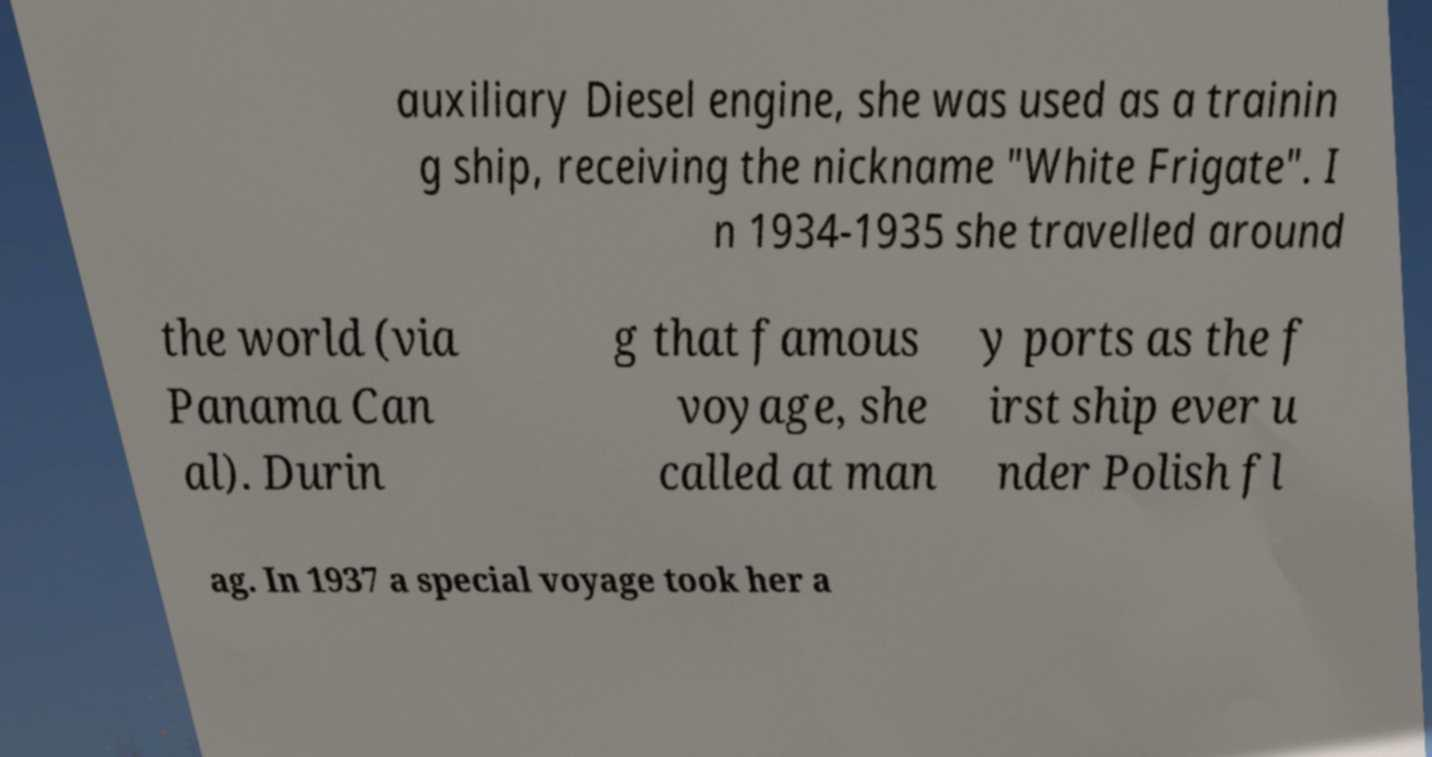Could you extract and type out the text from this image? auxiliary Diesel engine, she was used as a trainin g ship, receiving the nickname "White Frigate". I n 1934-1935 she travelled around the world (via Panama Can al). Durin g that famous voyage, she called at man y ports as the f irst ship ever u nder Polish fl ag. In 1937 a special voyage took her a 